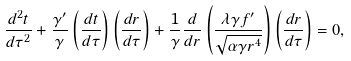Convert formula to latex. <formula><loc_0><loc_0><loc_500><loc_500>\frac { d ^ { 2 } t } { d \tau ^ { 2 } } + \frac { \gamma ^ { \prime } } { \gamma } \left ( \frac { d t } { d \tau } \right ) \left ( \frac { d r } { d \tau } \right ) + \frac { 1 } { \gamma } \frac { d } { d r } \left ( \frac { \lambda \gamma f ^ { \prime } } { \sqrt { \alpha \gamma r ^ { 4 } } } \right ) \left ( \frac { d r } { d \tau } \right ) = 0 ,</formula> 